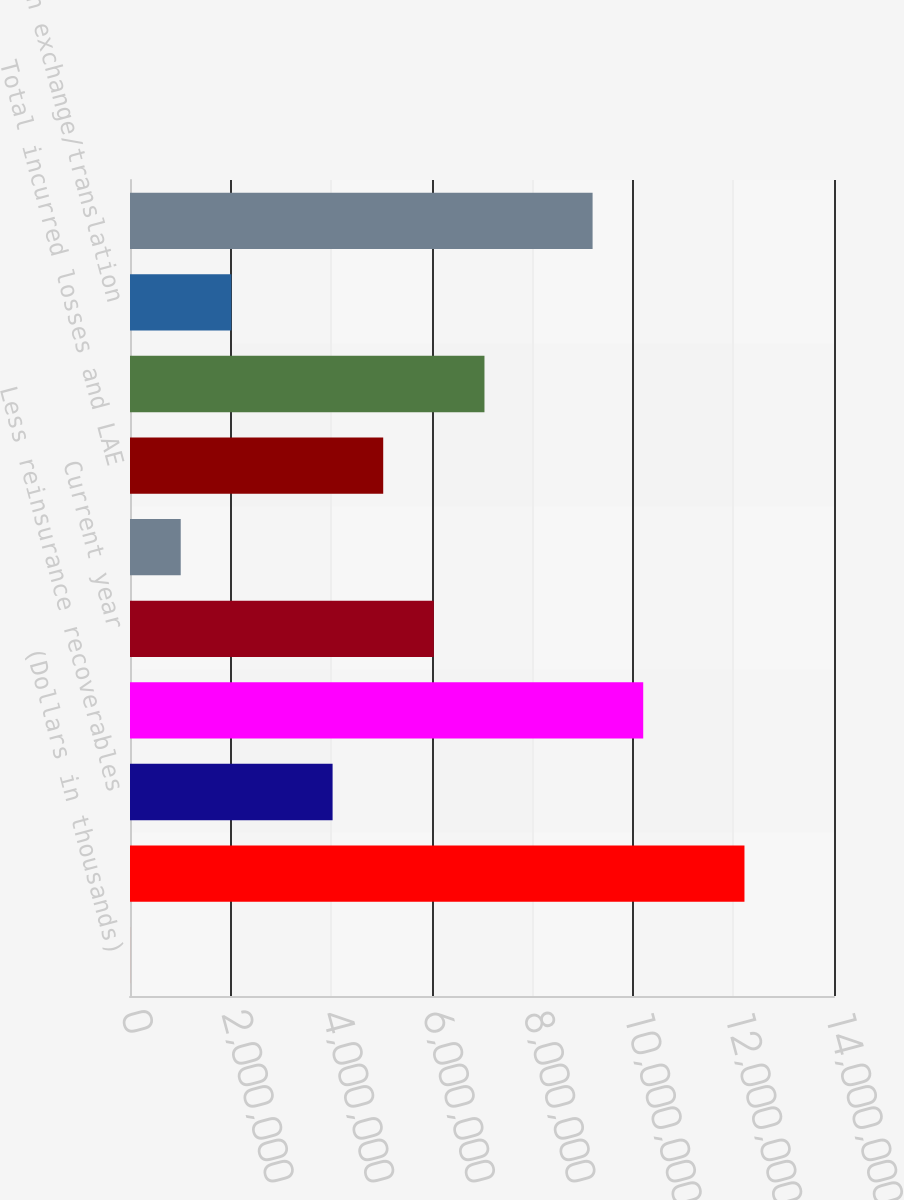Convert chart. <chart><loc_0><loc_0><loc_500><loc_500><bar_chart><fcel>(Dollars in thousands)<fcel>Gross reserves at January 1<fcel>Less reinsurance recoverables<fcel>Net reserves at January 1<fcel>Current year<fcel>Prior years<fcel>Total incurred losses and LAE<fcel>Total paid losses and LAE<fcel>Foreign exchange/translation<fcel>Net reserves at December 31<nl><fcel>2013<fcel>1.22195e+07<fcel>4.02883e+06<fcel>1.02061e+07<fcel>6.04224e+06<fcel>1.00872e+06<fcel>5.03553e+06<fcel>7.04894e+06<fcel>2.01542e+06<fcel>9.19937e+06<nl></chart> 